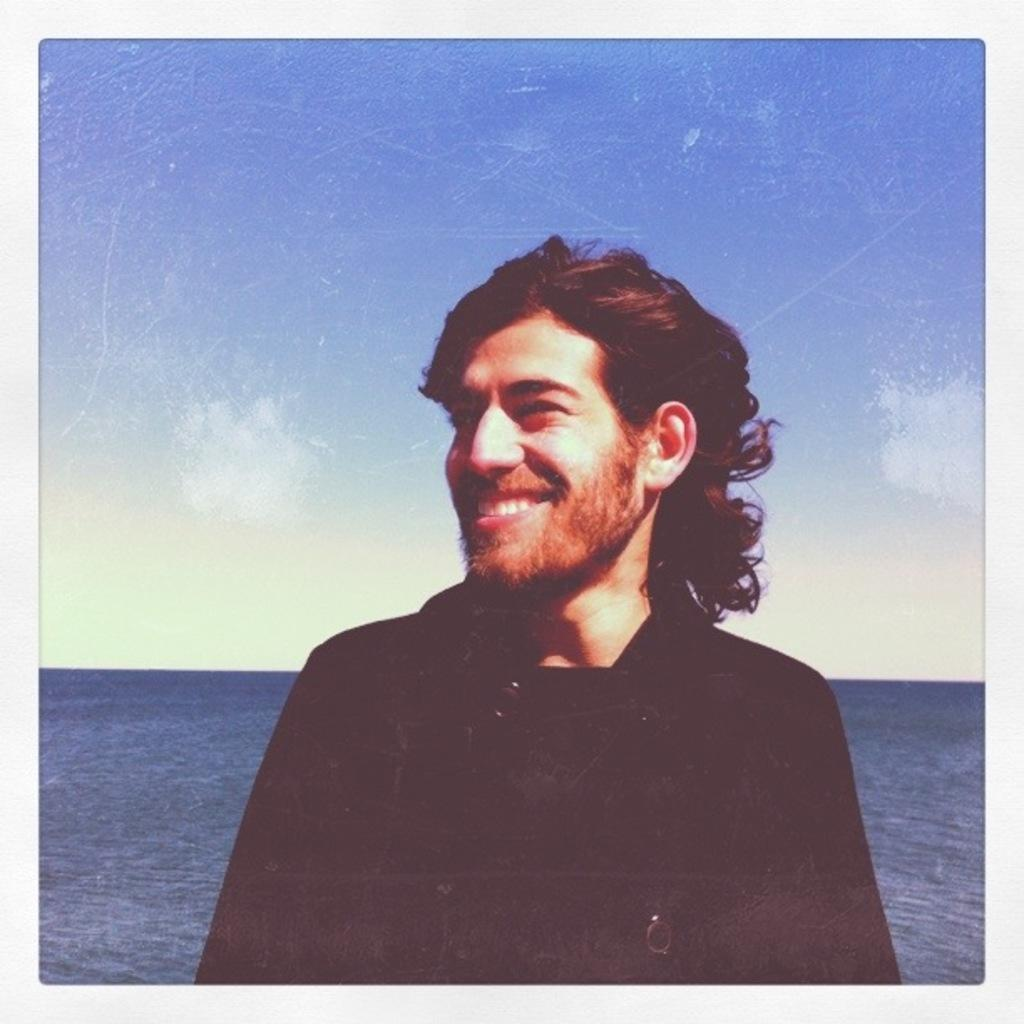Who is present in the image? There is a person in the image. What is the person's expression in the image? The person is smiling. What can be seen in the background of the image? There is a body of water (ocean) in the background of the image. What is the condition of the sky in the image? The sky is blue, and there are clouds in the sky. What type of eggs can be seen in the lunchroom in the image? There is no lunchroom or eggs present in the image; it features a person smiling with a blue sky and clouds in the background. 